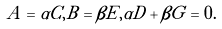Convert formula to latex. <formula><loc_0><loc_0><loc_500><loc_500>A = \alpha C , B = \beta E , \alpha D + \beta G = 0 .</formula> 